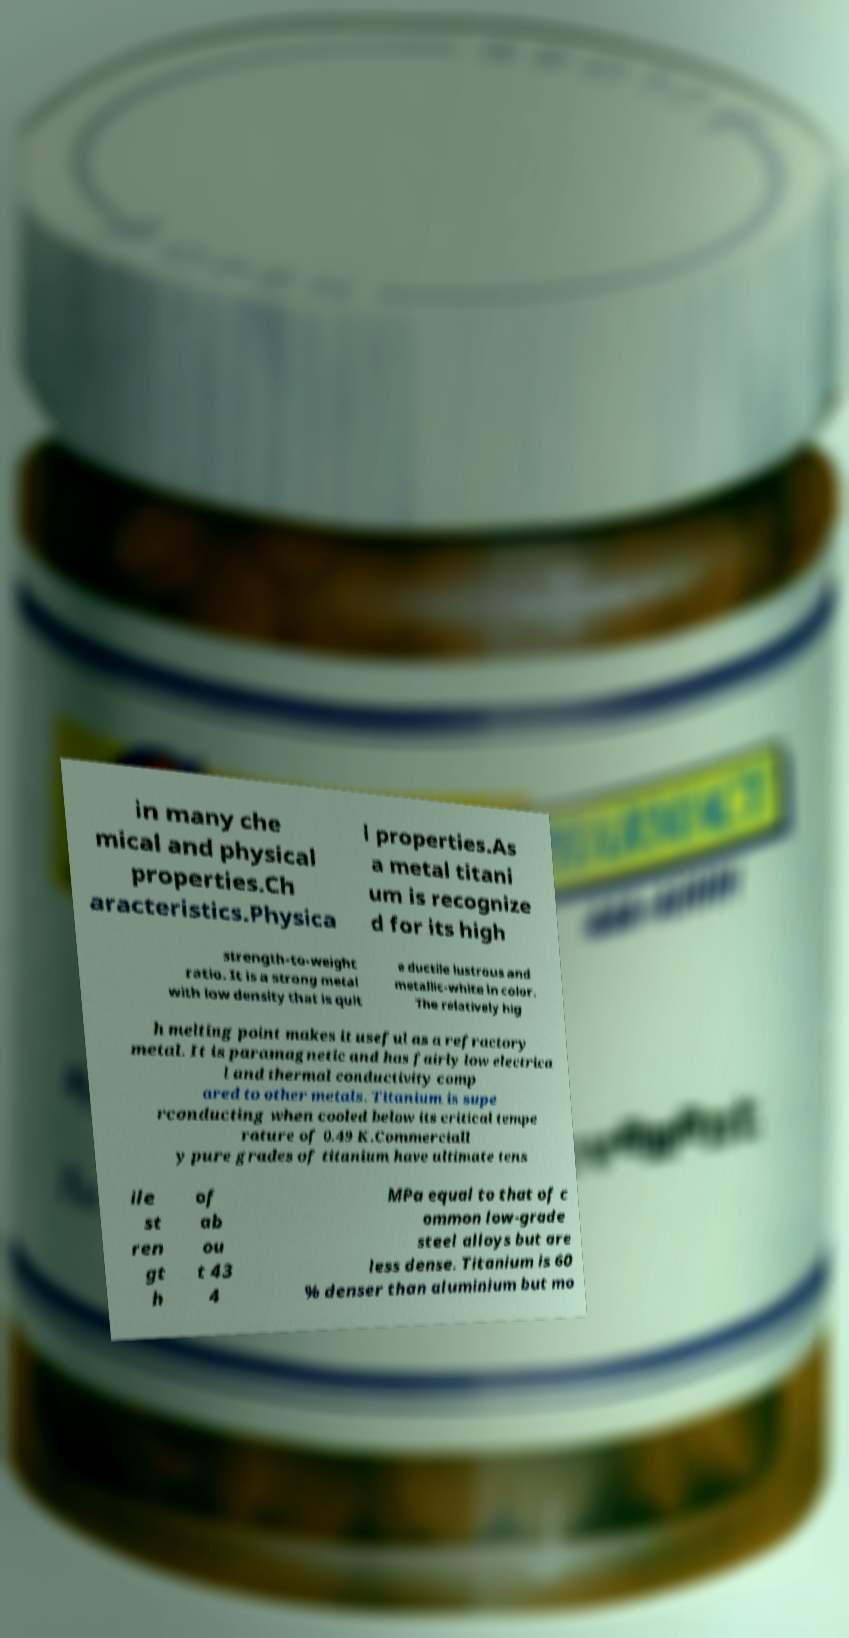Can you accurately transcribe the text from the provided image for me? in many che mical and physical properties.Ch aracteristics.Physica l properties.As a metal titani um is recognize d for its high strength-to-weight ratio. It is a strong metal with low density that is quit e ductile lustrous and metallic-white in color. The relatively hig h melting point makes it useful as a refractory metal. It is paramagnetic and has fairly low electrica l and thermal conductivity comp ared to other metals. Titanium is supe rconducting when cooled below its critical tempe rature of 0.49 K.Commerciall y pure grades of titanium have ultimate tens ile st ren gt h of ab ou t 43 4 MPa equal to that of c ommon low-grade steel alloys but are less dense. Titanium is 60 % denser than aluminium but mo 